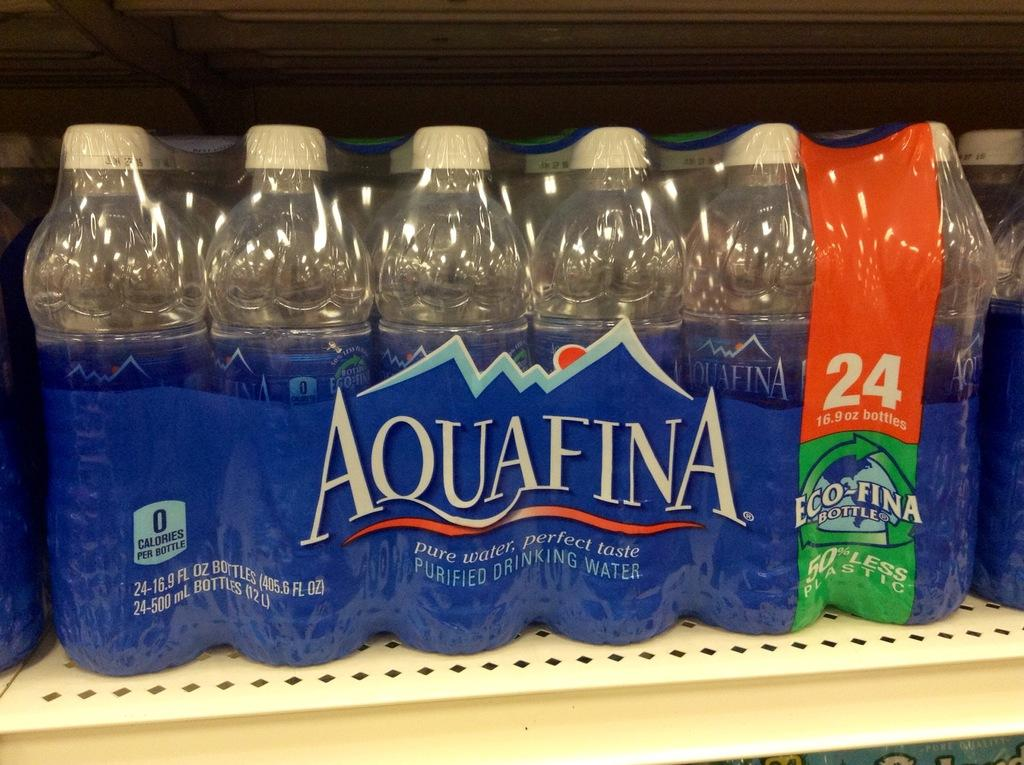<image>
Summarize the visual content of the image. A 24 bottle pack of Aquafina water sits on a store shelf. 